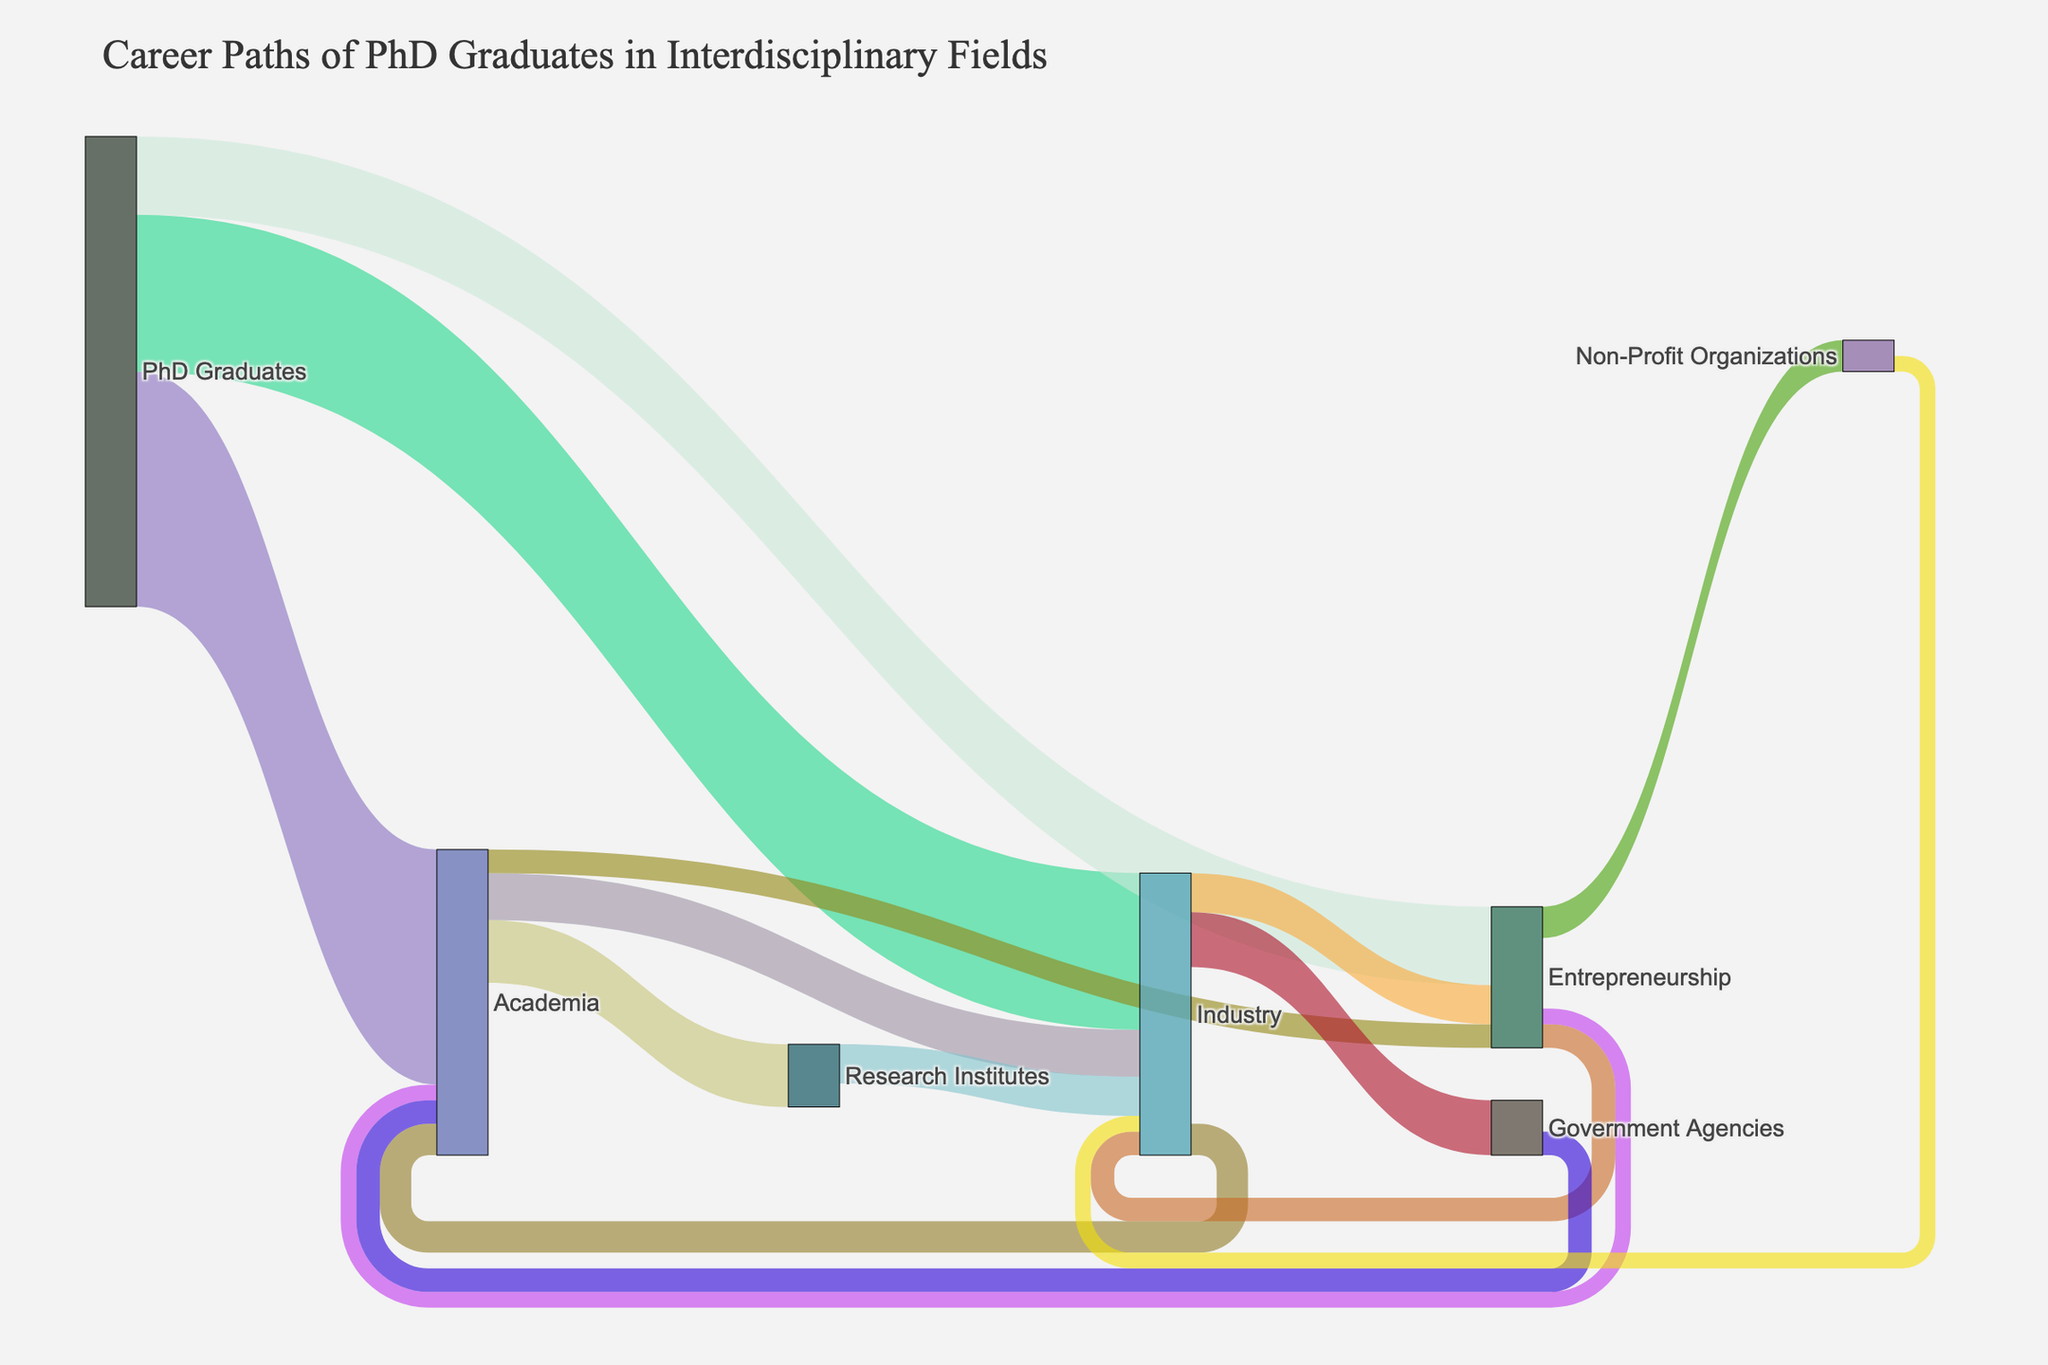What is the title of the figure? The title is usually displayed prominently at the top of the figure. The title helps contextualize the information presented in the Sankey Diagram.
Answer: Career Paths of PhD Graduates in Interdisciplinary Fields Which career path do the majority of PhD graduates initially enter? The Sankey Diagram shows the transitions from PhD Graduates to different career paths. By looking at the values attached to each path originating from PhD Graduates, we can identify the largest value.
Answer: Academia How many PhD graduates initially transition to Entrepreneurship? The diagram visually depicts the flow from PhD Graduates to different career paths. By locating the flow to Entrepreneurship and reading the associated value, we can find the answer.
Answer: 50 What is the combined value of PhD graduates who move from Academia to Industry and Entrepreneurship? To solve this, we look at the values for Academia to Industry and Academia to Entrepreneurship. By adding these values (30 + 15), we can get the combined value.
Answer: 45 Compare the number of PhD graduates moving from Industry to Academia with those moving from Academia to Industry. Which transition is larger? By examining the values associated with each transition (Industry to Academia and Academia to Industry), we find which number is greater. Values are 20 for Industry to Academia and 30 for Academia to Industry.
Answer: Academia to Industry Approximately what percentage of PhD graduates move into Industry directly after graduation? To find this, we look at the value of PhD graduates moving to Industry and divide this by the total number of PhD Graduates. The total is 300 (150 + 100 + 50), and 100 transitioned to Industry, so (100/300) x 100%.
Answer: 33.33% What is the total number of PhD graduates transitioning to Non-Profit Organizations from Entrepreneurship? The diagram shows direct transitions to different career paths. By looking at the specific flow from Entrepreneurship to Non-Profit Organizations, we read the value associated with it.
Answer: 20 How many PhD graduates transitioned across all paths from Industry? This requires summing all transitions originating from Industry: to Academia (20), to Entrepreneurship (25), and to Government Agencies (35).
Answer: 80 